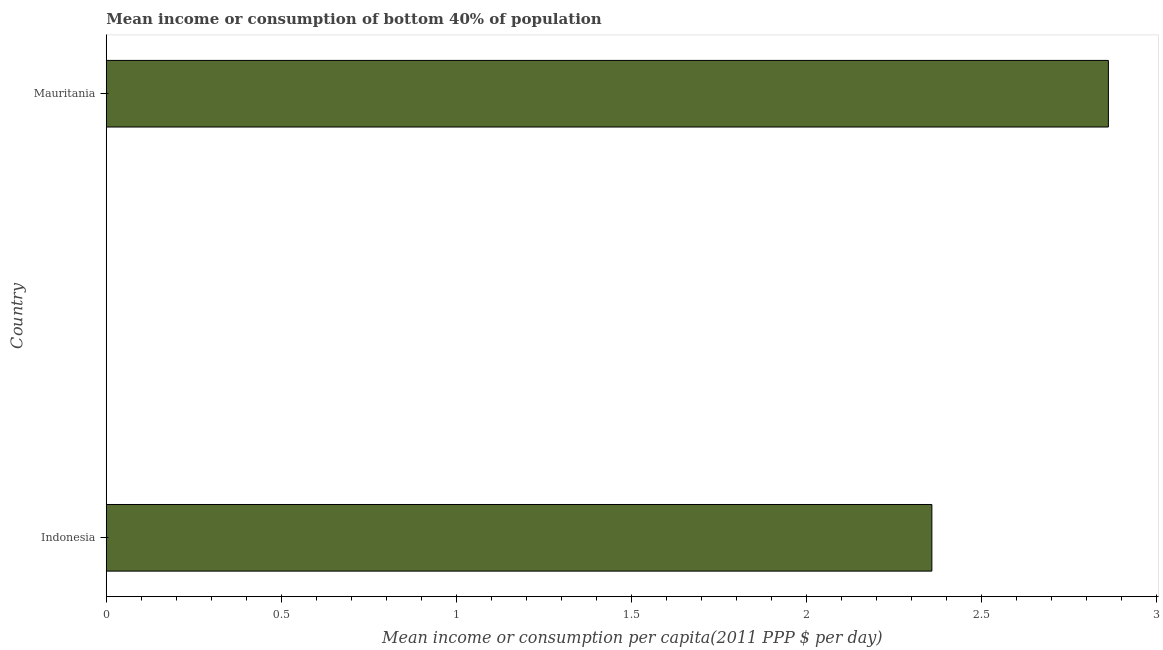Does the graph contain any zero values?
Your answer should be compact. No. Does the graph contain grids?
Your answer should be compact. No. What is the title of the graph?
Your answer should be very brief. Mean income or consumption of bottom 40% of population. What is the label or title of the X-axis?
Make the answer very short. Mean income or consumption per capita(2011 PPP $ per day). What is the label or title of the Y-axis?
Your answer should be compact. Country. What is the mean income or consumption in Indonesia?
Make the answer very short. 2.36. Across all countries, what is the maximum mean income or consumption?
Give a very brief answer. 2.86. Across all countries, what is the minimum mean income or consumption?
Offer a very short reply. 2.36. In which country was the mean income or consumption maximum?
Your answer should be very brief. Mauritania. In which country was the mean income or consumption minimum?
Offer a terse response. Indonesia. What is the sum of the mean income or consumption?
Your answer should be compact. 5.22. What is the difference between the mean income or consumption in Indonesia and Mauritania?
Your response must be concise. -0.5. What is the average mean income or consumption per country?
Provide a short and direct response. 2.61. What is the median mean income or consumption?
Ensure brevity in your answer.  2.61. In how many countries, is the mean income or consumption greater than 2.7 $?
Your answer should be very brief. 1. What is the ratio of the mean income or consumption in Indonesia to that in Mauritania?
Offer a very short reply. 0.82. Is the mean income or consumption in Indonesia less than that in Mauritania?
Ensure brevity in your answer.  Yes. How many bars are there?
Offer a very short reply. 2. Are all the bars in the graph horizontal?
Ensure brevity in your answer.  Yes. How many countries are there in the graph?
Offer a terse response. 2. Are the values on the major ticks of X-axis written in scientific E-notation?
Your response must be concise. No. What is the Mean income or consumption per capita(2011 PPP $ per day) of Indonesia?
Your answer should be very brief. 2.36. What is the Mean income or consumption per capita(2011 PPP $ per day) in Mauritania?
Ensure brevity in your answer.  2.86. What is the difference between the Mean income or consumption per capita(2011 PPP $ per day) in Indonesia and Mauritania?
Your answer should be compact. -0.5. What is the ratio of the Mean income or consumption per capita(2011 PPP $ per day) in Indonesia to that in Mauritania?
Provide a succinct answer. 0.82. 